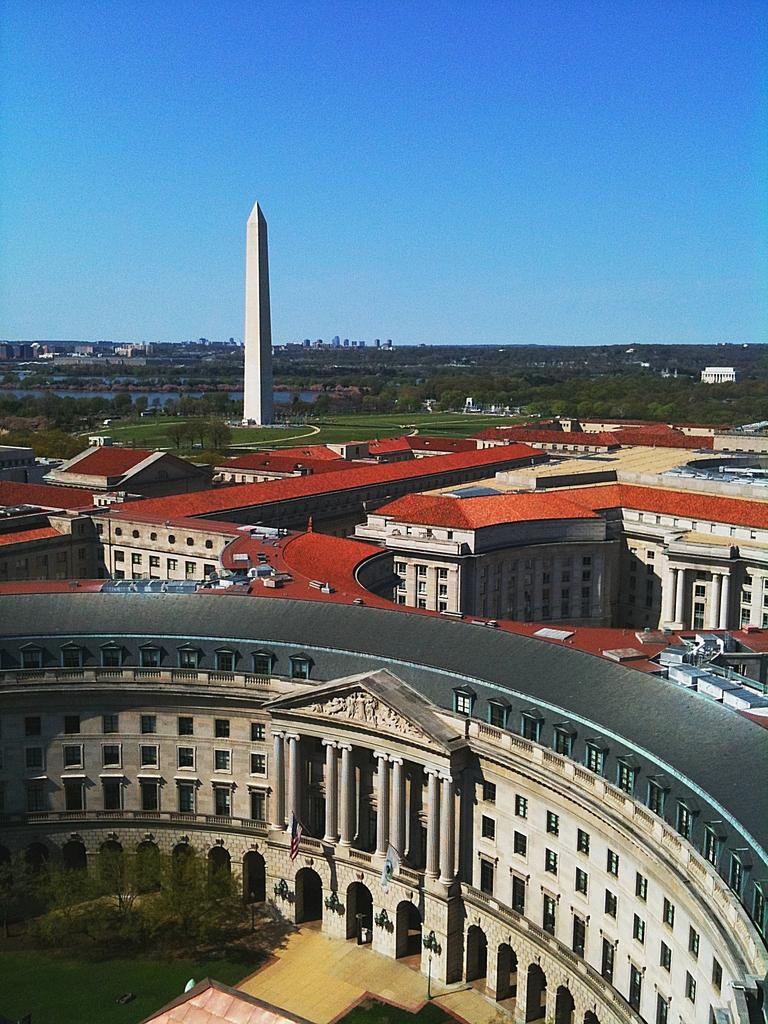What is the color of the sky in the image? The sky is blue in the image. What type of structures can be seen in the image? There are buildings and towers in the image. What type of vegetation is present in the image? There are trees and grass in the image. What architectural features can be seen in the image? There are windows and pillars in the image. What songs are being sung by the trees in the image? There are no songs being sung by the trees in the image, as trees do not have the ability to sing. 